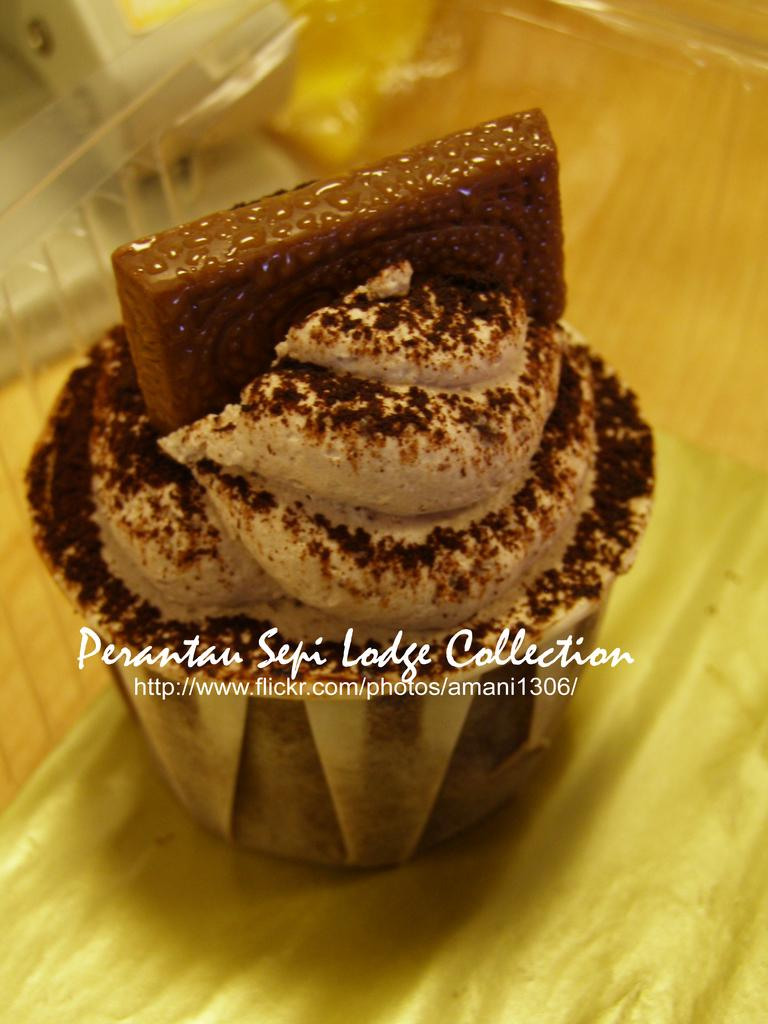What type of food item is visible in the image? There is a pastry in the image. Where is the pastry located? The pastry is in a box. Can you describe any additional features of the image? There is a watermark in the image. What type of hate can be seen in the image? There is no hate present in the image; it features a pastry in a box with a watermark. Can you recall any memories that are associated with the pastry in the image? The image does not provide any information about personal memories associated with the pastry. 